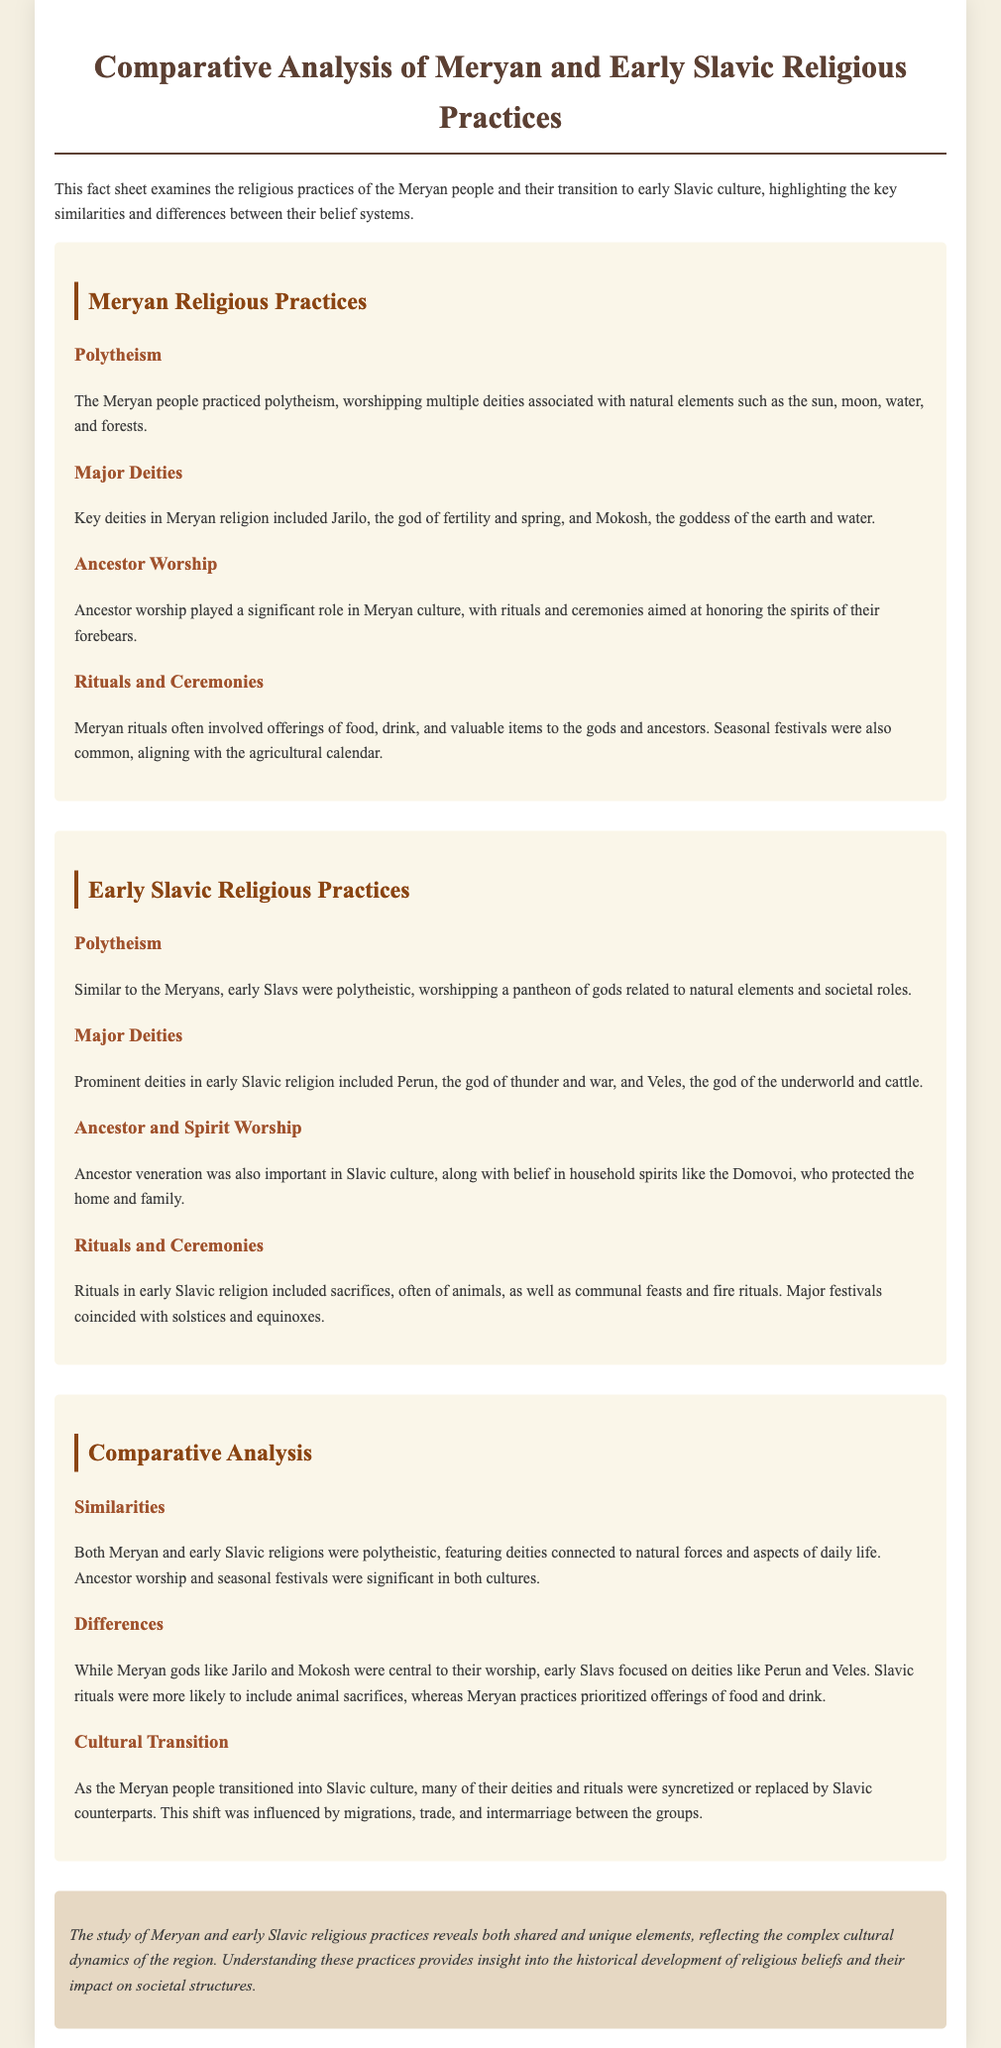what type of religious practice did the Meryan people follow? The Meryan people practiced polytheism, which is mentioned in the section about Meryan Religious Practices.
Answer: polytheism who is the goddess of the earth and water in Meryan religion? The document identifies Mokosh as the goddess of the earth and water under Major Deities in Meryan Religious Practices.
Answer: Mokosh which god is associated with thunder and war in early Slavic religion? The god associated with thunder and war is Perun, mentioned under Major Deities in Early Slavic Religious Practices.
Answer: Perun what significant role did ancestor worship play in Meryan culture? Ancestor worship played a significant role, as stated in the section on Ancestor Worship in Meryan Religious Practices.
Answer: significant role how did the rituals of the Meryan people primarily differ from those of early Slavs? The Meryan rituals prioritized offerings of food and drink, while early Slavic rituals often included animal sacrifices, highlighting differences in their practices.
Answer: offerings of food and drink what similarities existed between Meryan and early Slavic religious practices? Both Meryan and early Slavic religions were polytheistic and included ancestor worship and seasonal festivals, which suggests similarities in their belief systems.
Answer: polytheistic, ancestor worship, seasonal festivals which deity in early Slavic religion represents the underworld and cattle? The deity representing the underworld and cattle in early Slavic religion is Veles, mentioned in the section on Major Deities.
Answer: Veles what was a major influence that facilitated the transition of the Meryan people into Slavic culture? The transition was influenced by migrations, trade, and intermarriage, as stated in the Cultural Transition section.
Answer: migrations, trade, and intermarriage what type of document is this fact sheet? The fact sheet is a comparative analysis that discusses the religious practices of two cultures, as evident from the title and introduction.
Answer: comparative analysis 